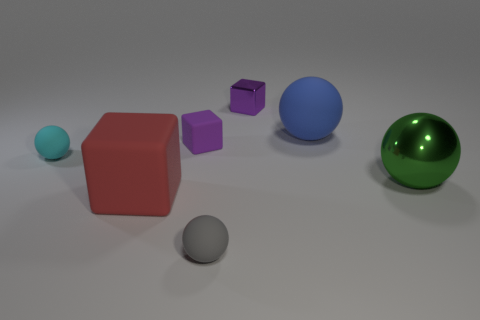What number of other things are there of the same color as the big matte block?
Provide a succinct answer. 0. Is the number of small cubes less than the number of cubes?
Give a very brief answer. Yes. The rubber object that is left of the gray matte object and behind the cyan matte thing is what color?
Offer a terse response. Purple. There is a small gray object that is the same shape as the blue object; what material is it?
Your answer should be compact. Rubber. Are there any other things that have the same size as the blue rubber object?
Offer a terse response. Yes. Are there more blocks than gray matte things?
Provide a short and direct response. Yes. How big is the matte sphere that is both behind the big green object and on the left side of the tiny purple metal block?
Ensure brevity in your answer.  Small. The large blue object has what shape?
Ensure brevity in your answer.  Sphere. How many gray rubber things are the same shape as the cyan thing?
Ensure brevity in your answer.  1. Are there fewer red blocks that are behind the green metallic object than big blue things that are in front of the cyan sphere?
Your answer should be very brief. No. 